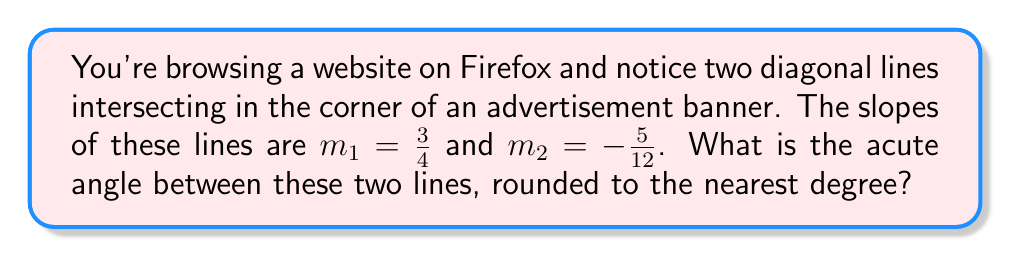Provide a solution to this math problem. To find the angle between two intersecting lines, we can use the formula:

$$\tan \theta = \left|\frac{m_1 - m_2}{1 + m_1m_2}\right|$$

Where $\theta$ is the angle between the lines, and $m_1$ and $m_2$ are the slopes of the two lines.

Let's solve this step-by-step:

1) We have $m_1 = \frac{3}{4}$ and $m_2 = -\frac{5}{12}$

2) Substituting these into the formula:

   $$\tan \theta = \left|\frac{\frac{3}{4} - (-\frac{5}{12})}{1 + \frac{3}{4}(-\frac{5}{12})}\right|$$

3) Simplify the numerator:
   $$\frac{3}{4} + \frac{5}{12} = \frac{9}{12} + \frac{5}{12} = \frac{14}{12} = \frac{7}{6}$$

4) Simplify the denominator:
   $$1 + \frac{3}{4}(-\frac{5}{12}) = 1 - \frac{15}{48} = \frac{48}{48} - \frac{15}{48} = \frac{33}{48}$$

5) Our equation now looks like:

   $$\tan \theta = \left|\frac{\frac{7}{6}}{\frac{33}{48}}\right|$$

6) Divide these fractions:

   $$\tan \theta = \left|\frac{7}{6} \cdot \frac{48}{33}\right| = \left|\frac{56}{33}\right| = \frac{56}{33}$$

7) To find $\theta$, we need to take the inverse tangent (arctan) of both sides:

   $$\theta = \arctan(\frac{56}{33})$$

8) Using a calculator, we get:

   $$\theta \approx 59.54^\circ$$

9) Rounding to the nearest degree:

   $$\theta \approx 60^\circ$$
Answer: The acute angle between the two lines is approximately 60°. 